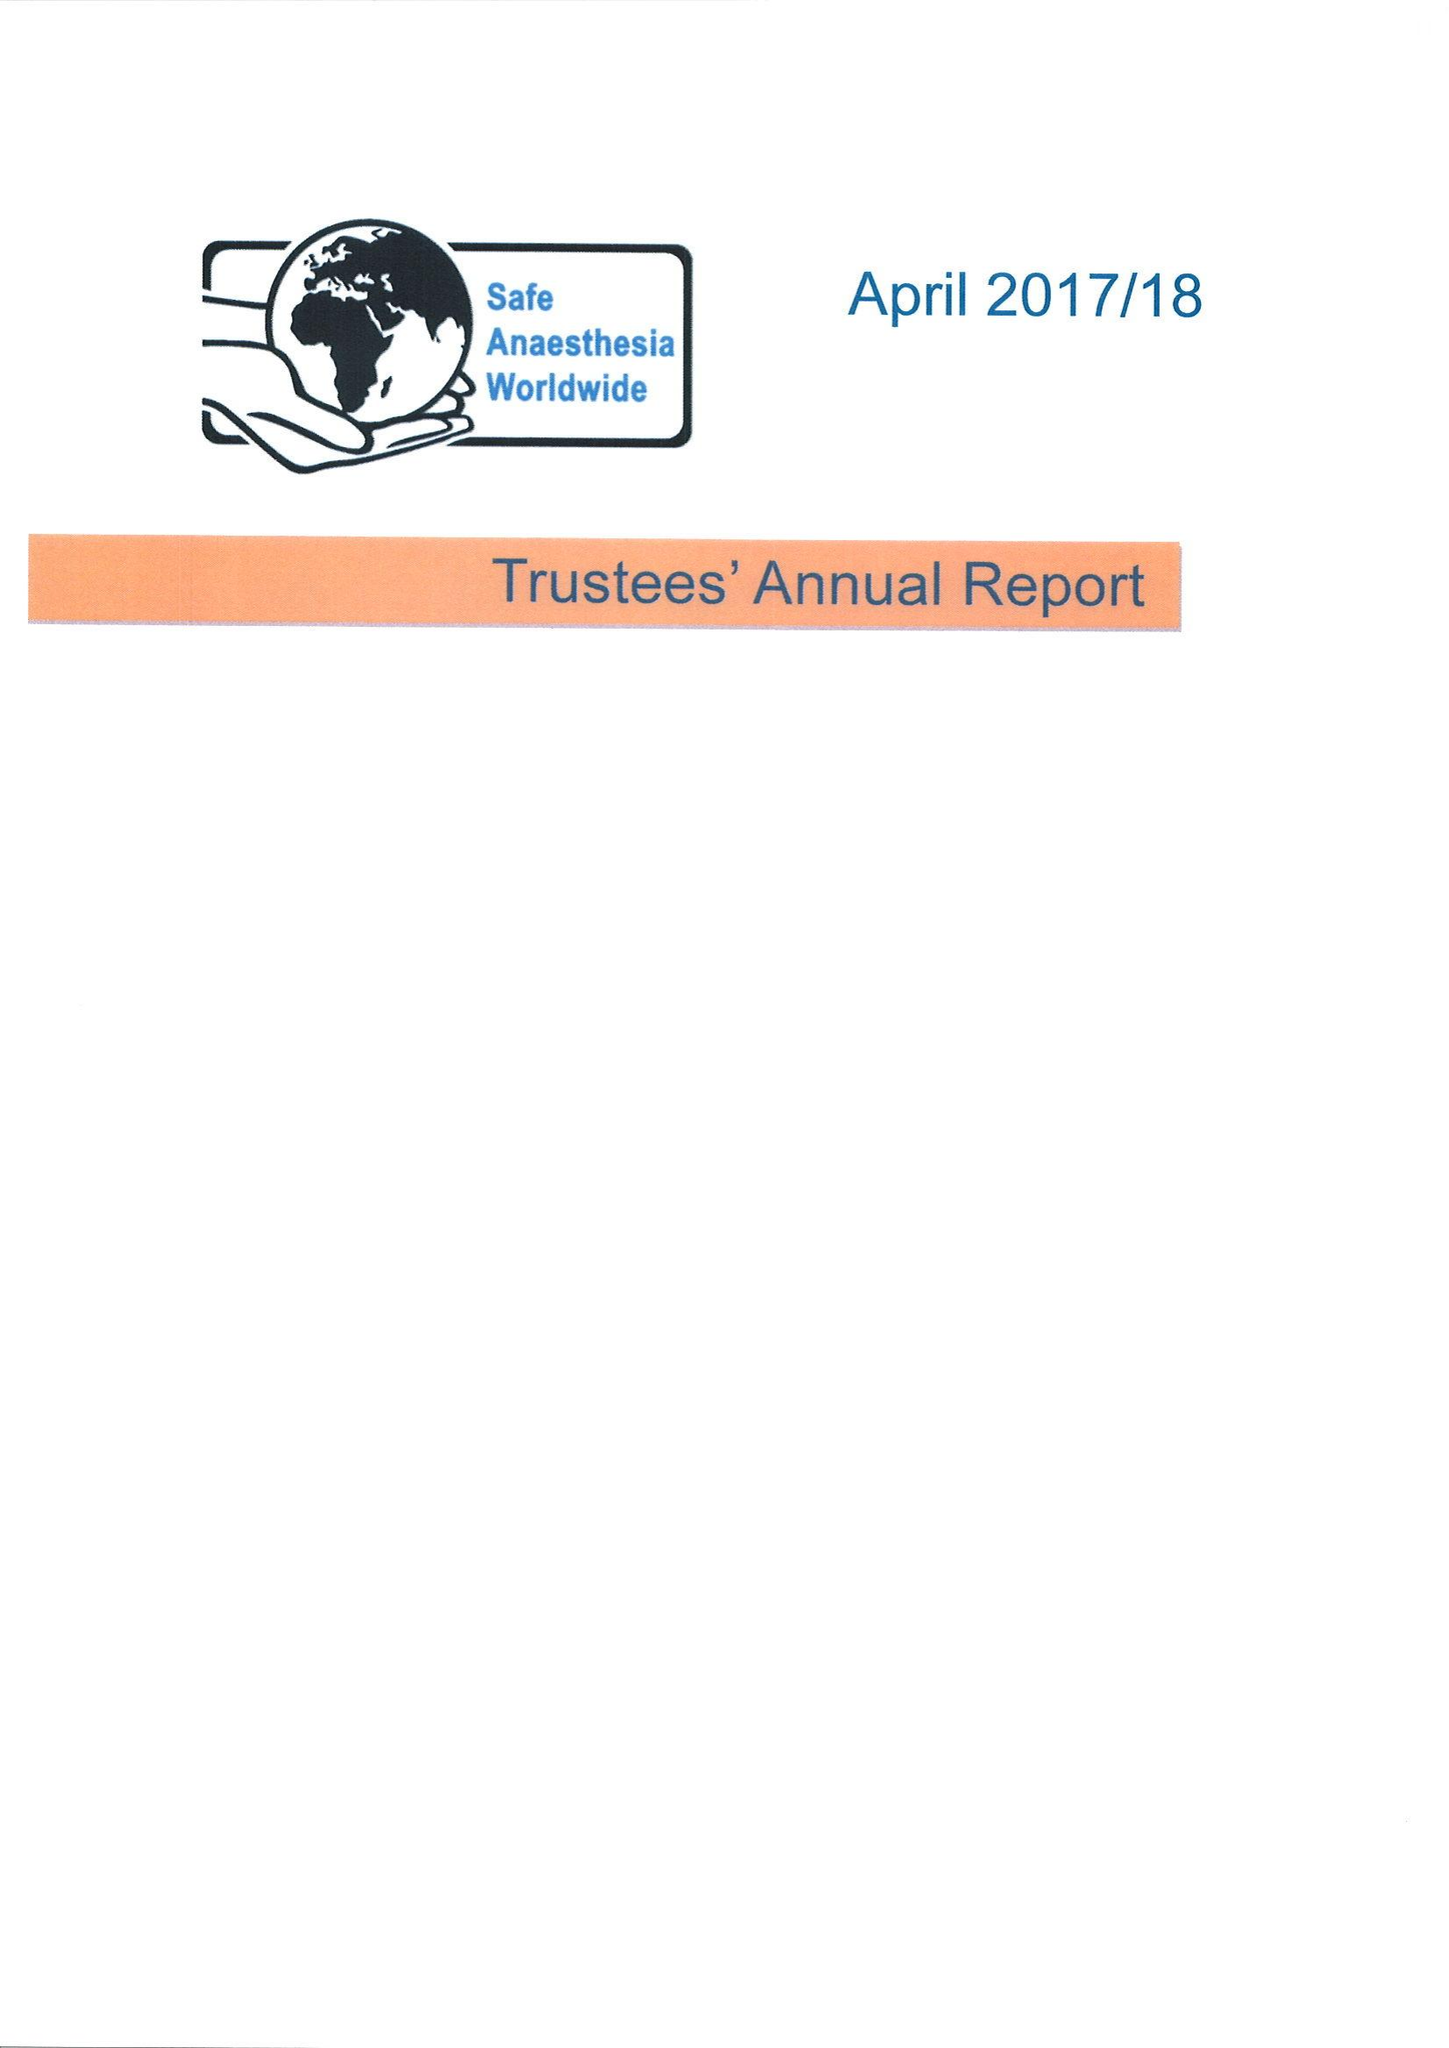What is the value for the address__postcode?
Answer the question using a single word or phrase. TN12 9DR 